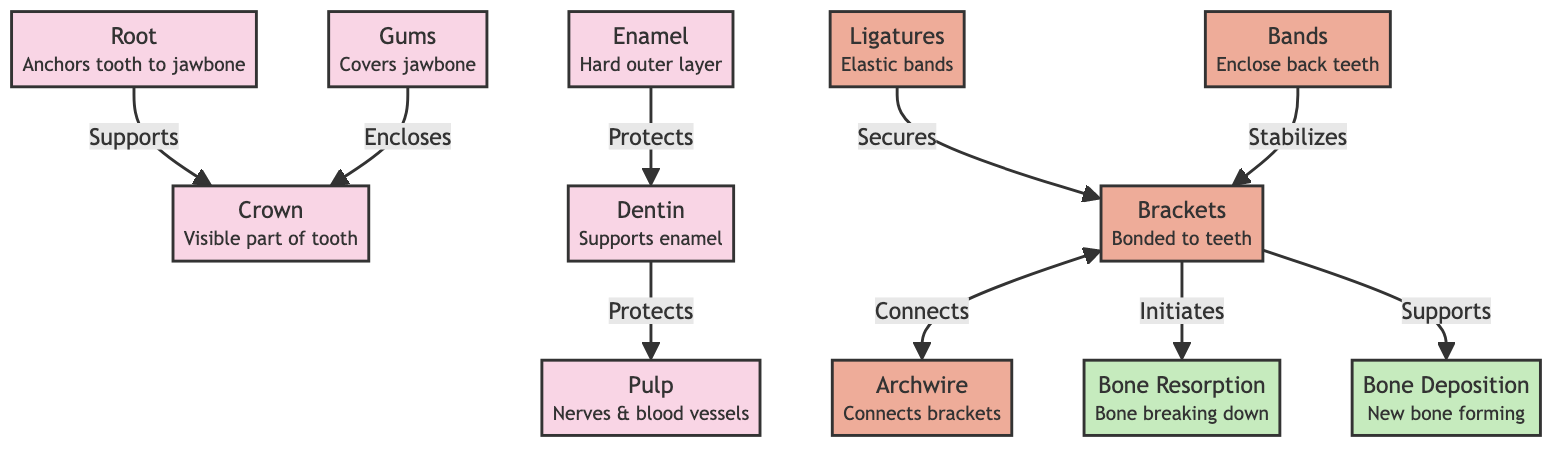What is the visible part of the tooth called? The diagram shows a labeled connection titled "Crown" which indicates that this is the visible part of the tooth.
Answer: Crown How many main parts are there in the tooth structure? The diagram illustrates five main parts: Root, Crown, Enamel, Dentin, and Pulp, which totals to five parts.
Answer: 5 What connects the brackets in braces? The diagram indicates that "Archwire" connects the brackets, illustrating their relationship clearly.
Answer: Archwire What type of tissue covers the jawbone? The diagram identifies "Gums" as the tissue that covers the jawbone, pointing to its protective function.
Answer: Gums What role do ligatures play in braces? According to the diagram, ligatures "Secure" the brackets, showing their function in the braces system.
Answer: Secures What initiates bone resorption? The diagram states that brackets "Initiate" bone resorption, linking braces directly to this process.
Answer: Brackets How does bone deposition relate to braces? The diagram specifies that brackets "Support" bone deposition, illustrating a key role that braces play in new bone formation.
Answer: Supports Which part of the tooth protects the pulp? The "Dentin" is shown in the diagram as the part that "Protects" the pulp, indicating its protective role.
Answer: Dentin What is the function of enamel? The diagram shows that "Enamel" protects "Dentin," hinting at its essential role in safeguarding the tooth structure.
Answer: Protects 